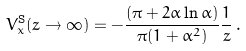Convert formula to latex. <formula><loc_0><loc_0><loc_500><loc_500>V _ { x } ^ { \text {S} } ( z \to \infty ) = - \frac { ( \pi + 2 \alpha \ln \alpha ) } { \pi ( 1 + \alpha ^ { 2 } ) } \frac { 1 } { z } \, .</formula> 